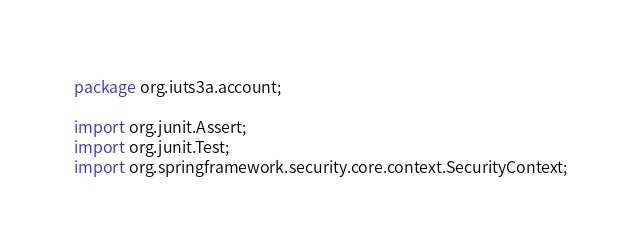Convert code to text. <code><loc_0><loc_0><loc_500><loc_500><_Java_>package org.iuts3a.account;

import org.junit.Assert;
import org.junit.Test;
import org.springframework.security.core.context.SecurityContext;</code> 